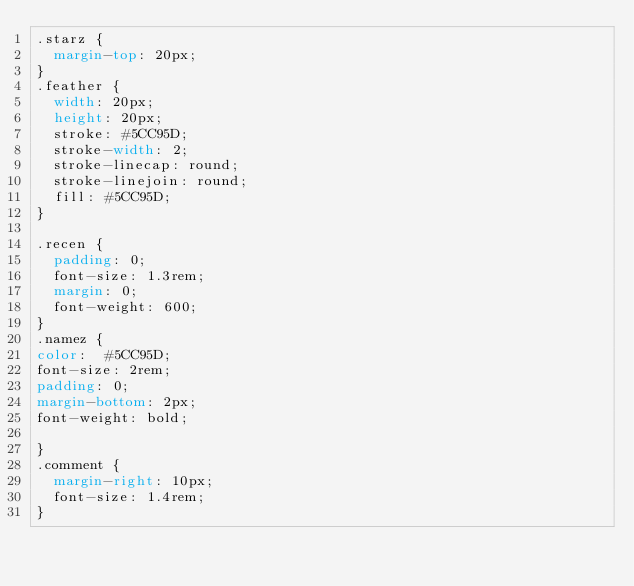Convert code to text. <code><loc_0><loc_0><loc_500><loc_500><_CSS_>.starz {
  margin-top: 20px;
}
.feather {
  width: 20px;
  height: 20px;
  stroke: #5CC95D;
  stroke-width: 2;
  stroke-linecap: round;
  stroke-linejoin: round;
  fill: #5CC95D;
}

.recen {
  padding: 0;
  font-size: 1.3rem;
  margin: 0;
  font-weight: 600;
}
.namez {
color:  #5CC95D;
font-size: 2rem;
padding: 0;
margin-bottom: 2px;
font-weight: bold;

}
.comment {
  margin-right: 10px;
  font-size: 1.4rem;
}</code> 